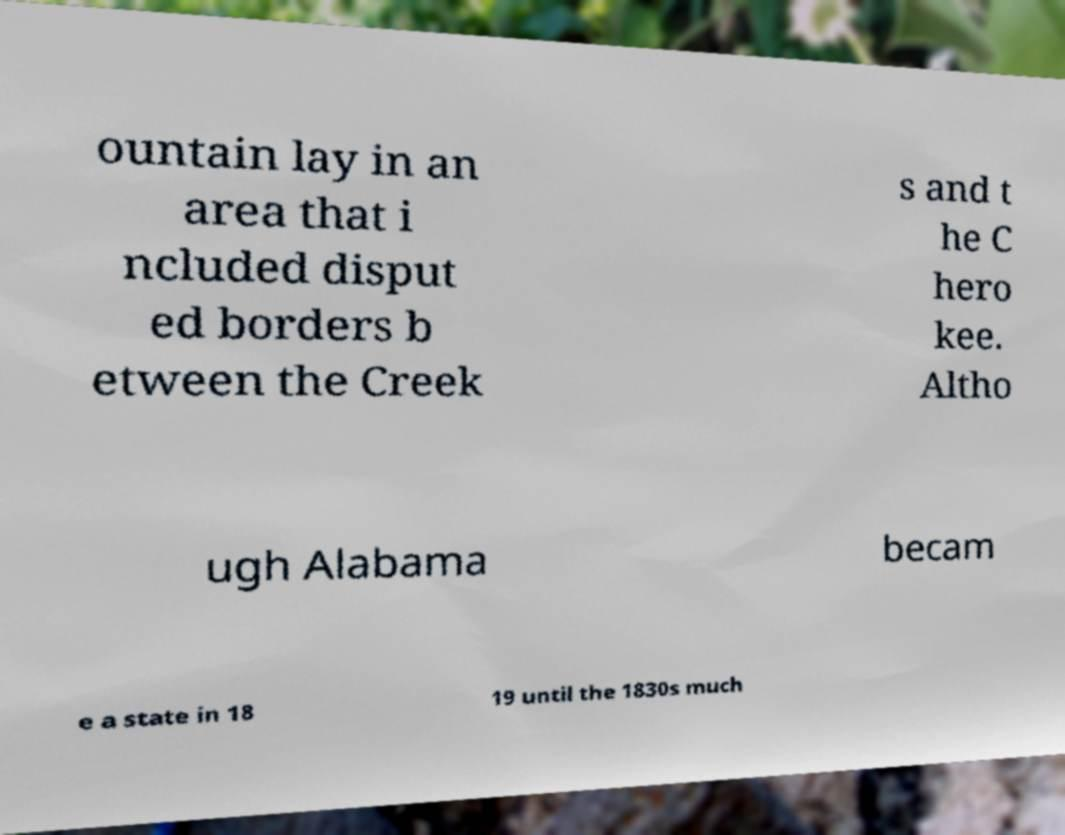Can you accurately transcribe the text from the provided image for me? ountain lay in an area that i ncluded disput ed borders b etween the Creek s and t he C hero kee. Altho ugh Alabama becam e a state in 18 19 until the 1830s much 